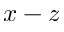<formula> <loc_0><loc_0><loc_500><loc_500>x - z</formula> 